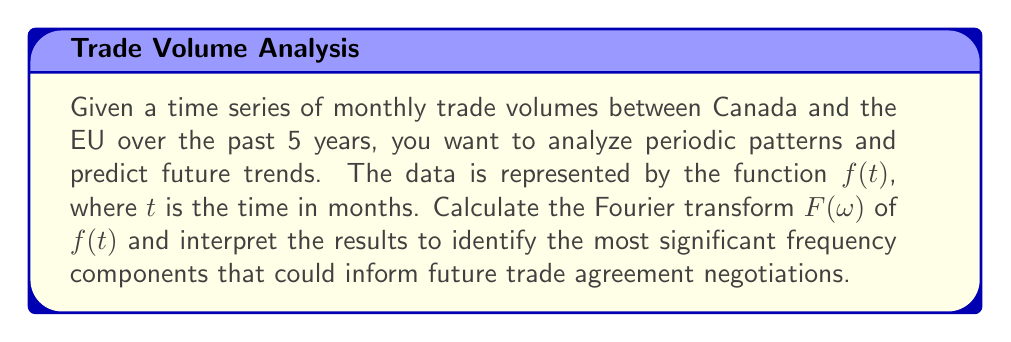What is the answer to this math problem? To solve this problem, we'll follow these steps:

1) The Fourier transform of a continuous-time function $f(t)$ is given by:

   $$F(\omega) = \int_{-\infty}^{\infty} f(t) e^{-i\omega t} dt$$

2) For discrete time series data, we use the Discrete Fourier Transform (DFT):

   $$F(k) = \sum_{n=0}^{N-1} f(n) e^{-i2\pi kn/N}$$

   where $N$ is the number of data points, $n$ is the time index, and $k$ is the frequency index.

3) For 5 years of monthly data, we have $N = 5 * 12 = 60$ data points.

4) Compute the DFT using a Fast Fourier Transform (FFT) algorithm.

5) The magnitude of $F(k)$ represents the strength of each frequency component.

6) Identify the peaks in $|F(k)|$. The corresponding frequencies are:

   $$\omega_k = \frac{2\pi k}{N} \text{ (in radians per month)}$$

7) Convert to cycles per year:

   $$f_k = \frac{\omega_k}{2\pi} * 12 \text{ (cycles per year)}$$

8) Interpret the results:
   - A peak at $k=0$ represents the mean trade volume.
   - A peak at $k=5$ (f ≈ 1 cycle/year) suggests an annual pattern.
   - A peak at $k=10$ (f ≈ 2 cycles/year) suggests a semi-annual pattern.
   - Other peaks may indicate quarterly or monthly patterns.

9) The strongest frequency components suggest the most significant periodic patterns in trade volumes, which can inform predictions and negotiations.
Answer: Compute DFT, identify peak frequencies, convert to cycles/year, interpret for trade patterns. 